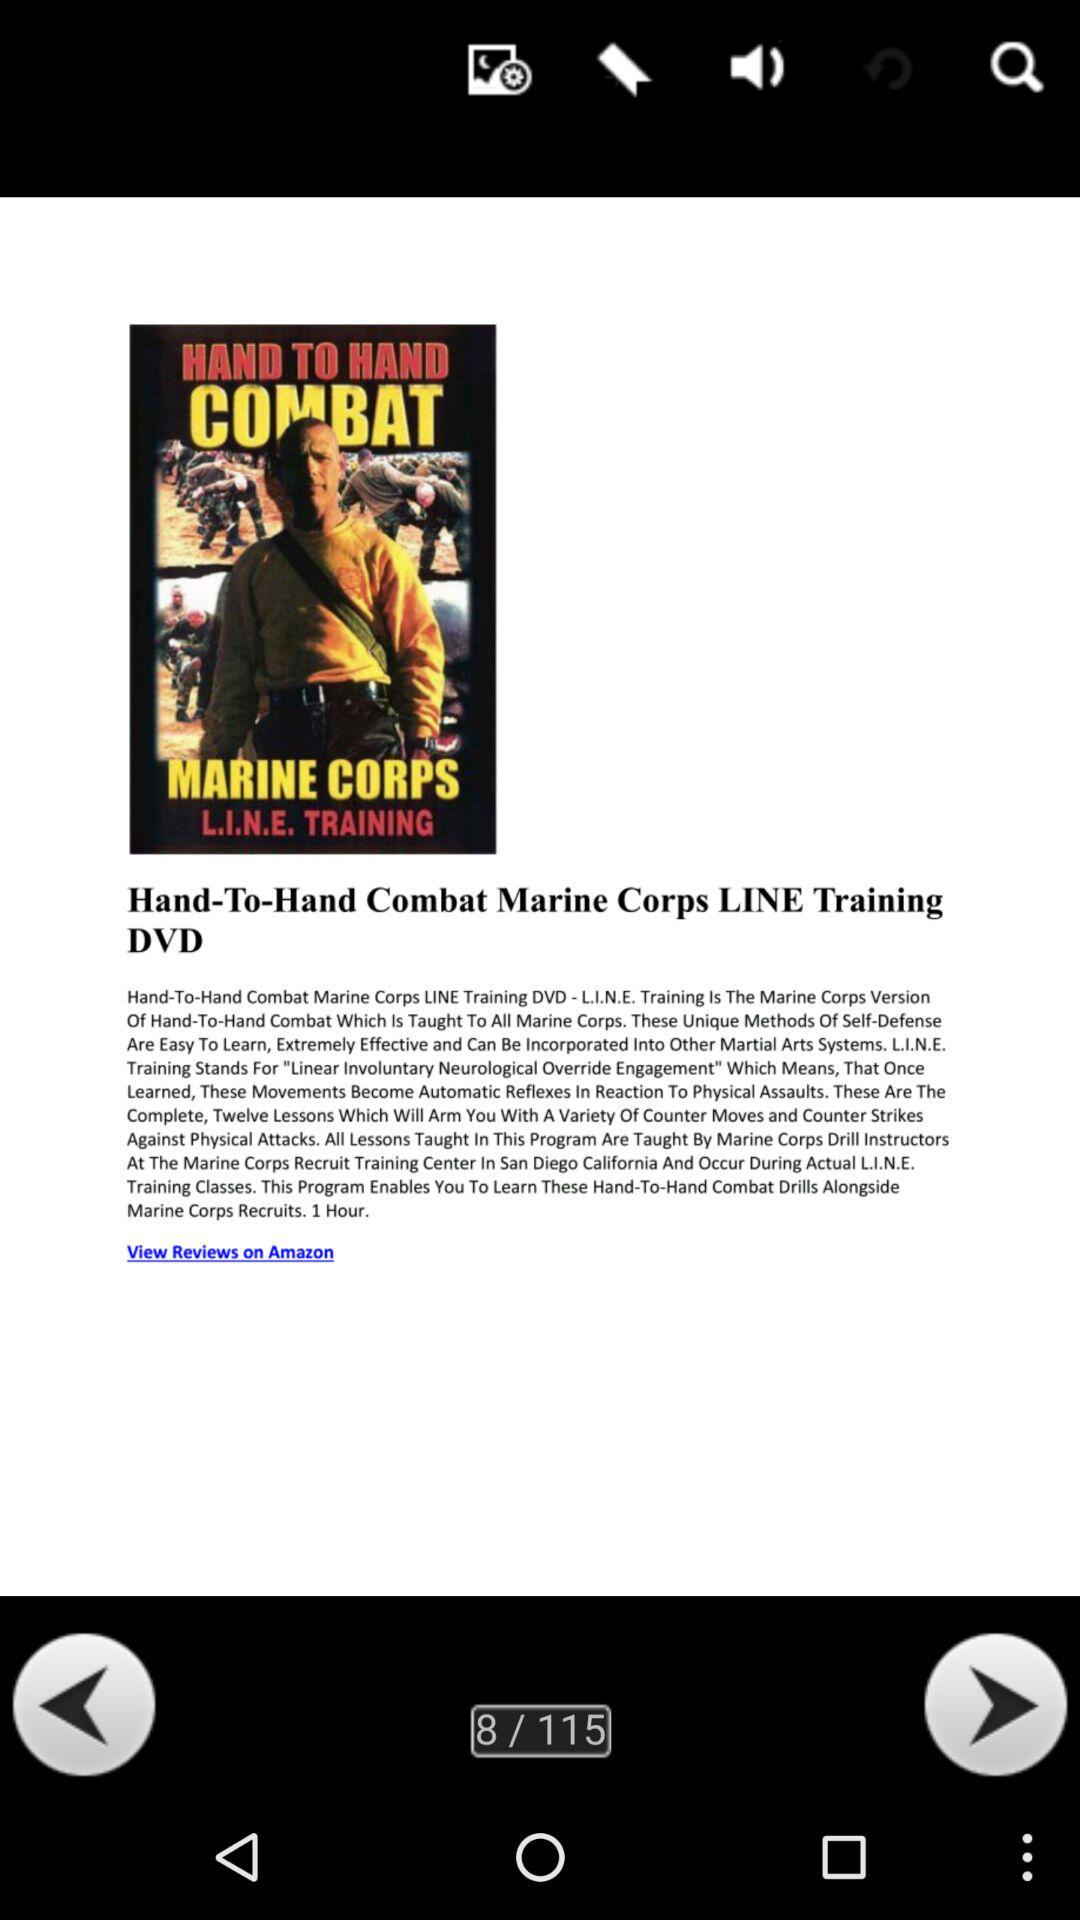What is the number of slides? The number of slides is 115. 